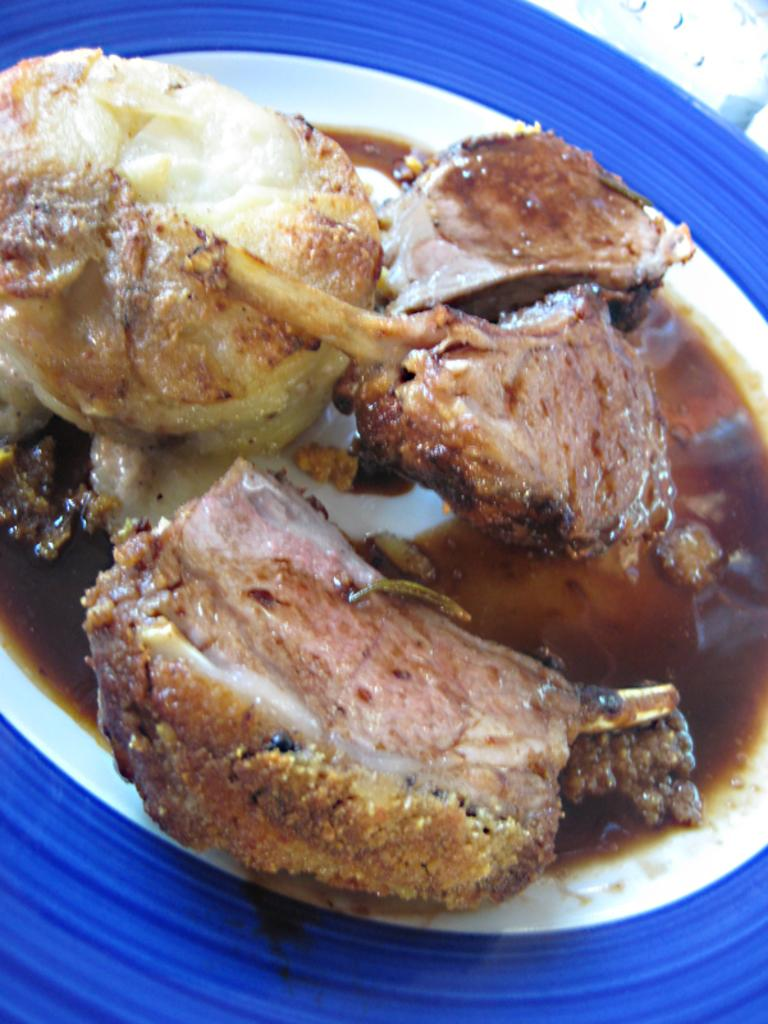What is the main subject of the image? The main subject of the image is a dish. What can you tell me about the container holding the dish? The dish is served in a blue object. What type of fish can be seen swimming in the dish in the image? There is no fish present in the image; it only features a dish served in a blue object. What kind of music is the band playing in the background of the image? There is no band or music present in the image; it only features a dish served in a blue object. 